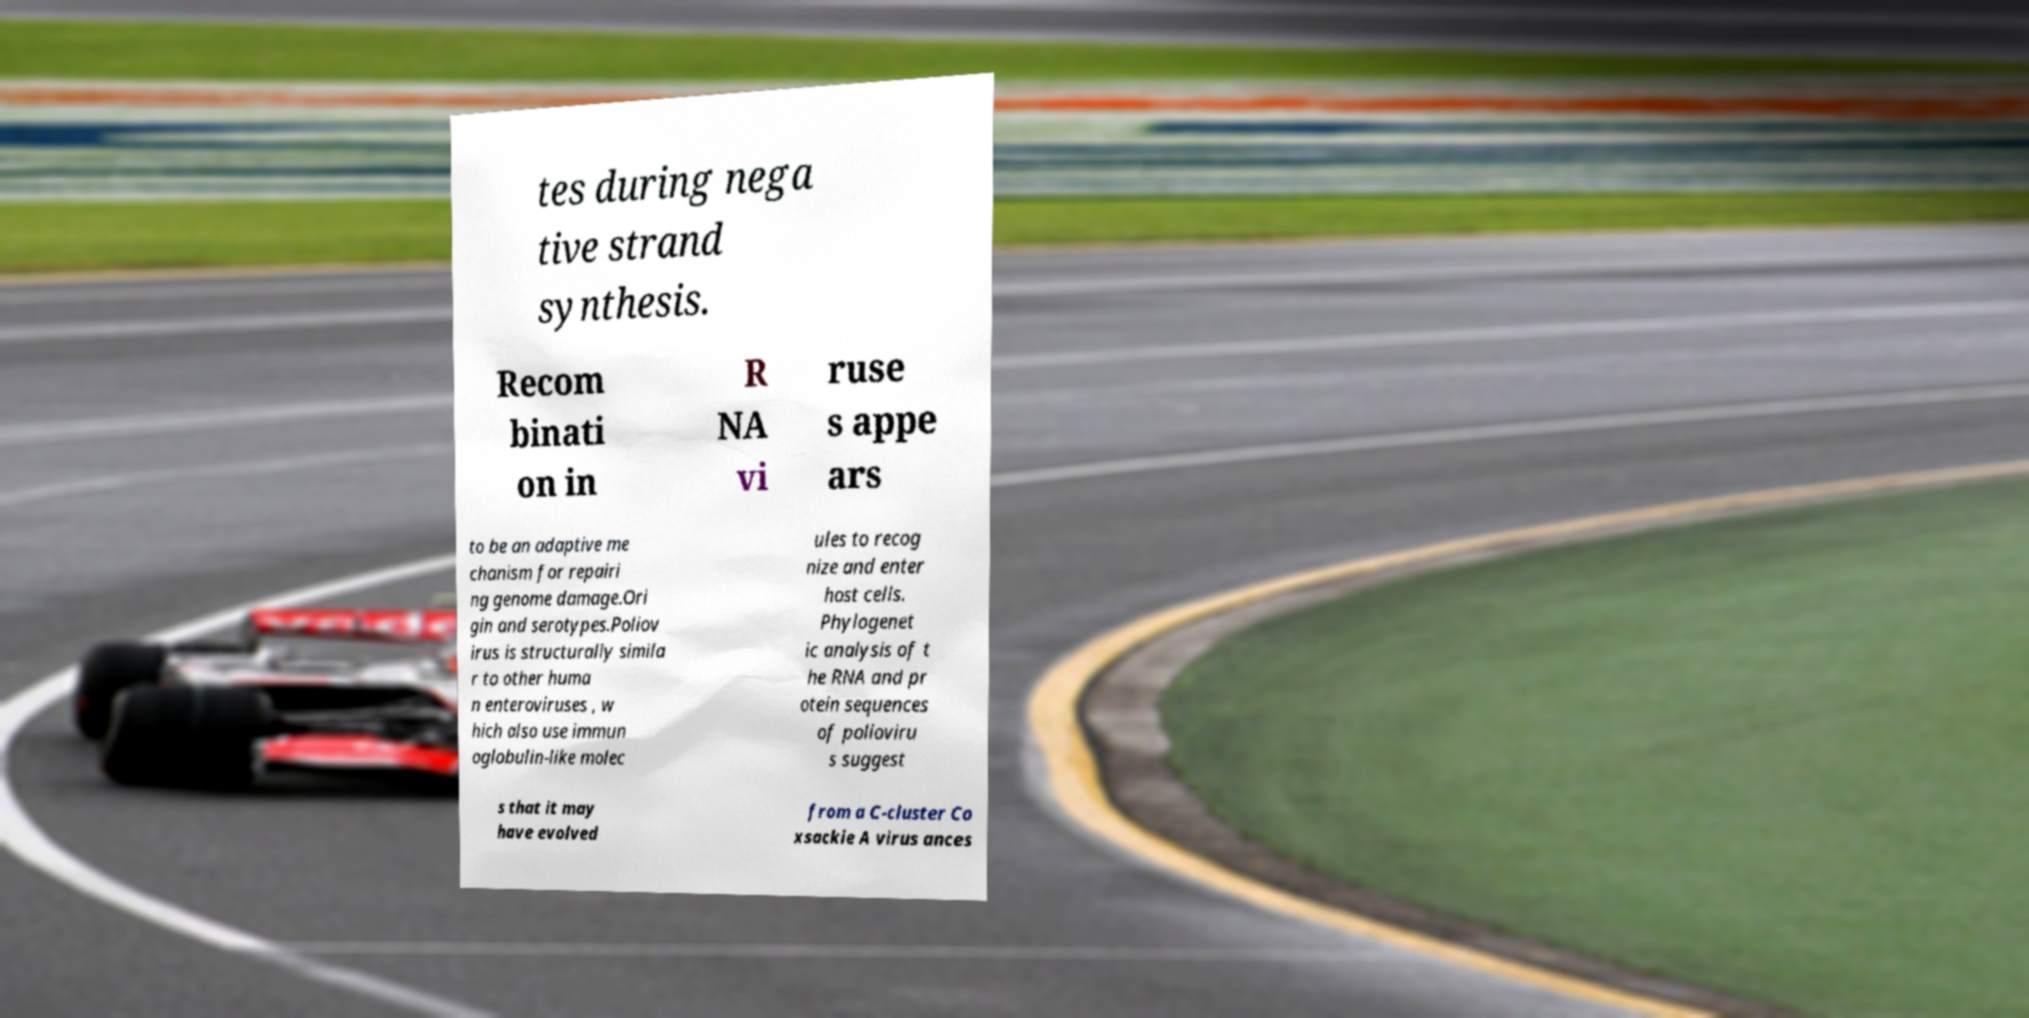Could you extract and type out the text from this image? tes during nega tive strand synthesis. Recom binati on in R NA vi ruse s appe ars to be an adaptive me chanism for repairi ng genome damage.Ori gin and serotypes.Poliov irus is structurally simila r to other huma n enteroviruses , w hich also use immun oglobulin-like molec ules to recog nize and enter host cells. Phylogenet ic analysis of t he RNA and pr otein sequences of polioviru s suggest s that it may have evolved from a C-cluster Co xsackie A virus ances 